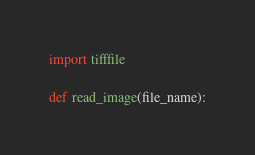<code> <loc_0><loc_0><loc_500><loc_500><_Python_>import tifffile

def read_image(file_name):</code> 